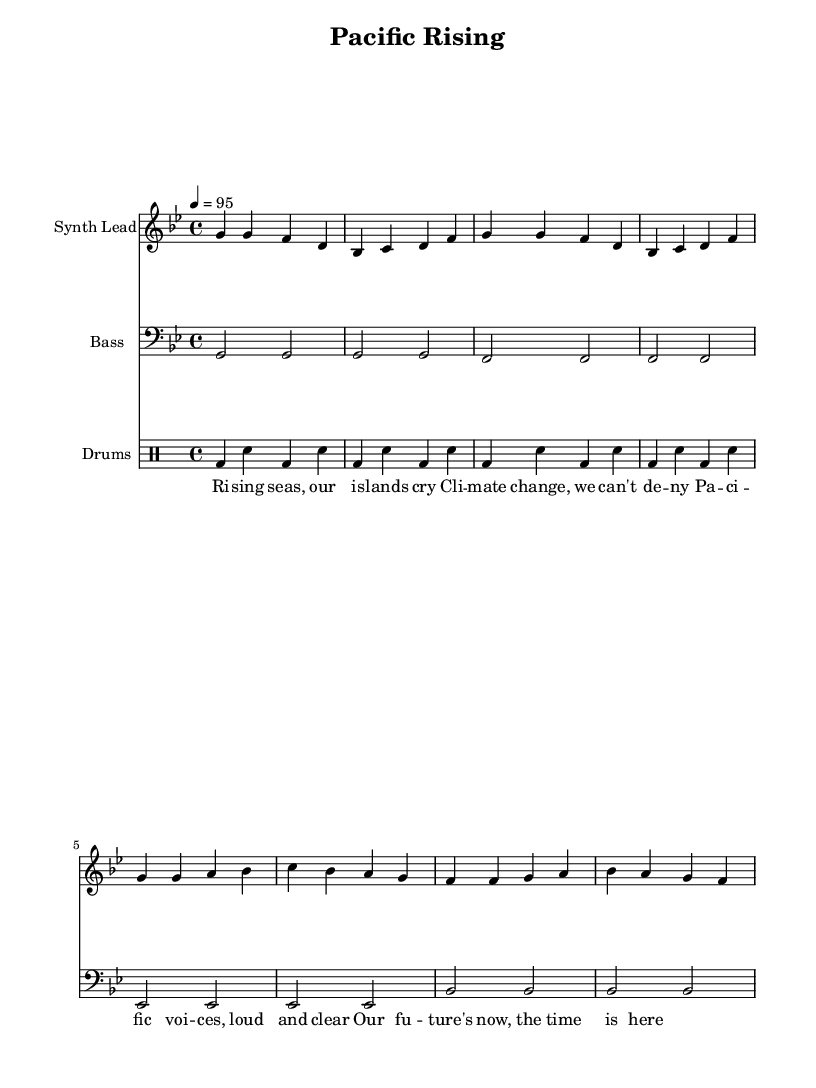what is the key signature of this music? The key signature is identified by looking at the initial symbols before the notes. The music is in G minor, which has two flats.
Answer: G minor what is the time signature of this music? The time signature is found at the beginning of the score, right after the key signature. Here, it is written as 4/4, indicating four beats per measure.
Answer: 4/4 what is the tempo of this music? The tempo is indicated in beats per minute and is found at the beginning of the score. The tempo marking is "4 = 95", meaning there are 95 beats per minute.
Answer: 95 how many measures are in the synth lead part? To find the number of measures, count the number of groups of notes separated by vertical lines (bar lines) in the synth lead part. There are 8 measures in total.
Answer: 8 which instrument plays the bass part? The bass part is indicated by checking the instrument name associated with that staff. It clearly states "Bass" as the instrument that plays this part.
Answer: Bass how does the verse's lyrical theme relate to Pacific Island issues? The lyrics discuss climate change and the voice of the Pacific people, focusing on urgent issues affecting their lands and future, indicating a deep connection to Pacific Island concerns.
Answer: Climate change and Pacific voices what type of rhythm pattern does the drum machine use? The drum machine uses a common 4/4 rhythm pattern defined by kick drum and snare placements. Each measure has a combination of bass drum (bd) and snare drum (sn) in a steady alternating pattern.
Answer: Alternating kick and snare 